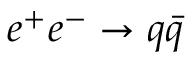Convert formula to latex. <formula><loc_0><loc_0><loc_500><loc_500>e ^ { + } e ^ { - } \to q \bar { q }</formula> 